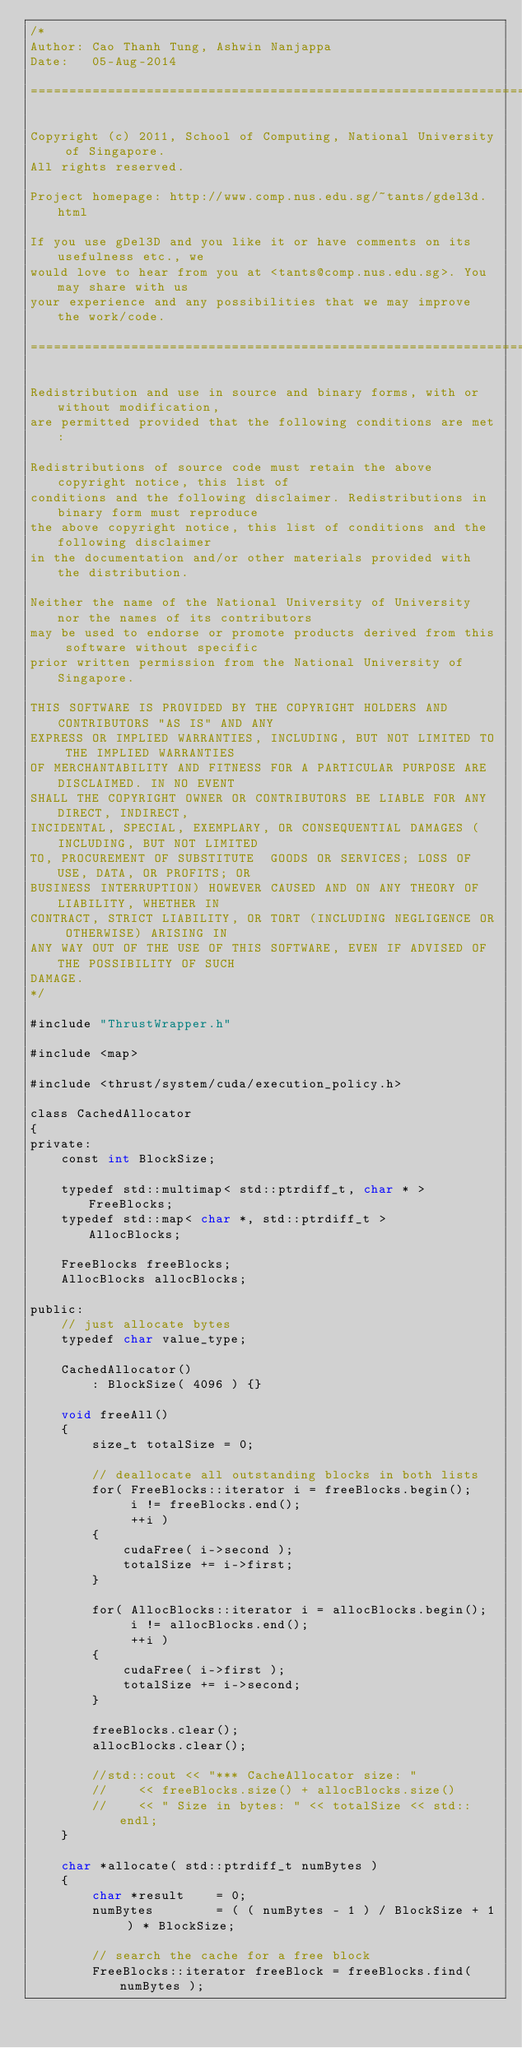<code> <loc_0><loc_0><loc_500><loc_500><_Cuda_>/*
Author: Cao Thanh Tung, Ashwin Nanjappa
Date:   05-Aug-2014

===============================================================================

Copyright (c) 2011, School of Computing, National University of Singapore. 
All rights reserved.

Project homepage: http://www.comp.nus.edu.sg/~tants/gdel3d.html

If you use gDel3D and you like it or have comments on its usefulness etc., we 
would love to hear from you at <tants@comp.nus.edu.sg>. You may share with us
your experience and any possibilities that we may improve the work/code.

===============================================================================

Redistribution and use in source and binary forms, with or without modification,
are permitted provided that the following conditions are met:

Redistributions of source code must retain the above copyright notice, this list of
conditions and the following disclaimer. Redistributions in binary form must reproduce
the above copyright notice, this list of conditions and the following disclaimer
in the documentation and/or other materials provided with the distribution. 

Neither the name of the National University of University nor the names of its contributors
may be used to endorse or promote products derived from this software without specific
prior written permission from the National University of Singapore. 

THIS SOFTWARE IS PROVIDED BY THE COPYRIGHT HOLDERS AND CONTRIBUTORS "AS IS" AND ANY
EXPRESS OR IMPLIED WARRANTIES, INCLUDING, BUT NOT LIMITED TO THE IMPLIED WARRANTIES 
OF MERCHANTABILITY AND FITNESS FOR A PARTICULAR PURPOSE ARE DISCLAIMED. IN NO EVENT
SHALL THE COPYRIGHT OWNER OR CONTRIBUTORS BE LIABLE FOR ANY DIRECT, INDIRECT,
INCIDENTAL, SPECIAL, EXEMPLARY, OR CONSEQUENTIAL DAMAGES (INCLUDING, BUT NOT LIMITED
TO, PROCUREMENT OF SUBSTITUTE  GOODS OR SERVICES; LOSS OF USE, DATA, OR PROFITS; OR
BUSINESS INTERRUPTION) HOWEVER CAUSED AND ON ANY THEORY OF LIABILITY, WHETHER IN
CONTRACT, STRICT LIABILITY, OR TORT (INCLUDING NEGLIGENCE OR OTHERWISE) ARISING IN
ANY WAY OUT OF THE USE OF THIS SOFTWARE, EVEN IF ADVISED OF THE POSSIBILITY OF SUCH
DAMAGE.
*/

#include "ThrustWrapper.h"

#include <map>

#include <thrust/system/cuda/execution_policy.h>

class CachedAllocator
{
private:
    const int BlockSize; 

    typedef std::multimap< std::ptrdiff_t, char * >     FreeBlocks;
    typedef std::map< char *, std::ptrdiff_t >          AllocBlocks;

    FreeBlocks freeBlocks;
    AllocBlocks allocBlocks;

public:
    // just allocate bytes
    typedef char value_type;

    CachedAllocator() 
        : BlockSize( 4096 ) {}

    void freeAll()
    {
        size_t totalSize = 0; 

        // deallocate all outstanding blocks in both lists
        for( FreeBlocks::iterator i = freeBlocks.begin();
             i != freeBlocks.end();
             ++i )
        {
            cudaFree( i->second );
            totalSize += i->first; 
        }

        for( AllocBlocks::iterator i = allocBlocks.begin();
             i != allocBlocks.end();
             ++i )
        {
            cudaFree( i->first );
            totalSize += i->second; 
        }

        freeBlocks.clear(); 
        allocBlocks.clear(); 

        //std::cout << "*** CacheAllocator size: " 
        //    << freeBlocks.size() + allocBlocks.size()
        //    << " Size in bytes: " << totalSize << std::endl;  
    }

    char *allocate( std::ptrdiff_t numBytes )
    {
        char *result    = 0;
        numBytes        = ( ( numBytes - 1 ) / BlockSize + 1 ) * BlockSize; 

        // search the cache for a free block
        FreeBlocks::iterator freeBlock = freeBlocks.find( numBytes );
</code> 